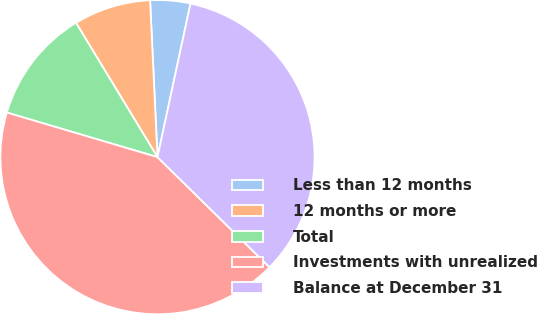<chart> <loc_0><loc_0><loc_500><loc_500><pie_chart><fcel>Less than 12 months<fcel>12 months or more<fcel>Total<fcel>Investments with unrealized<fcel>Balance at December 31<nl><fcel>4.12%<fcel>7.93%<fcel>11.74%<fcel>42.22%<fcel>33.99%<nl></chart> 